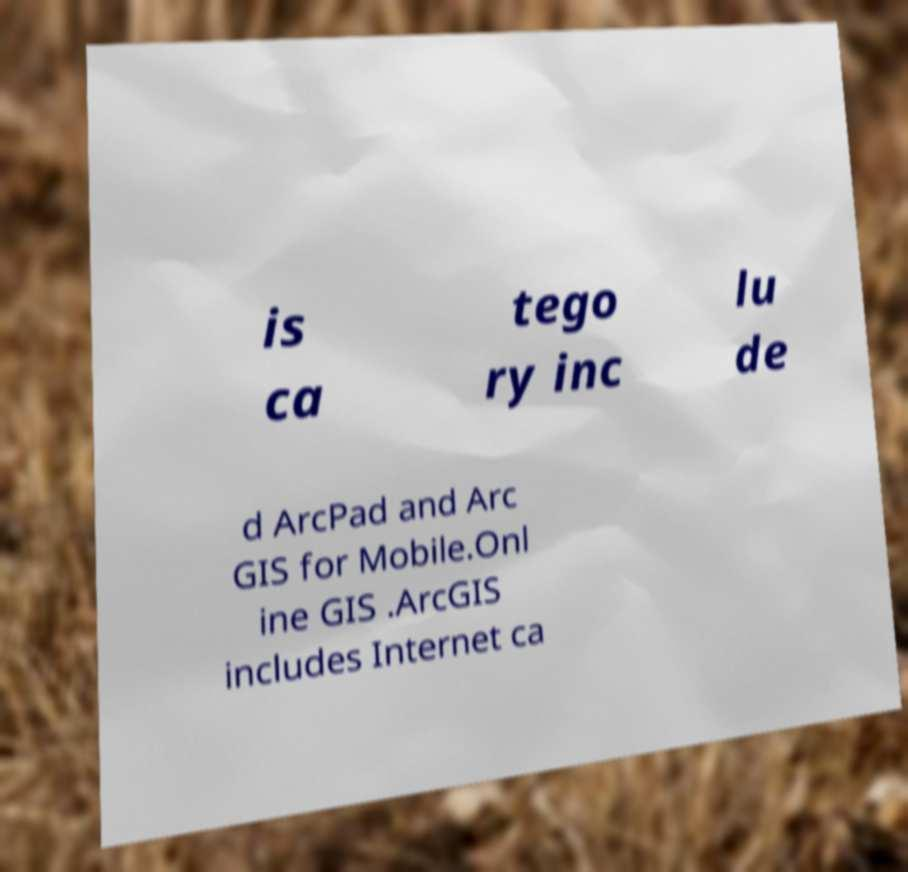Please read and relay the text visible in this image. What does it say? is ca tego ry inc lu de d ArcPad and Arc GIS for Mobile.Onl ine GIS .ArcGIS includes Internet ca 